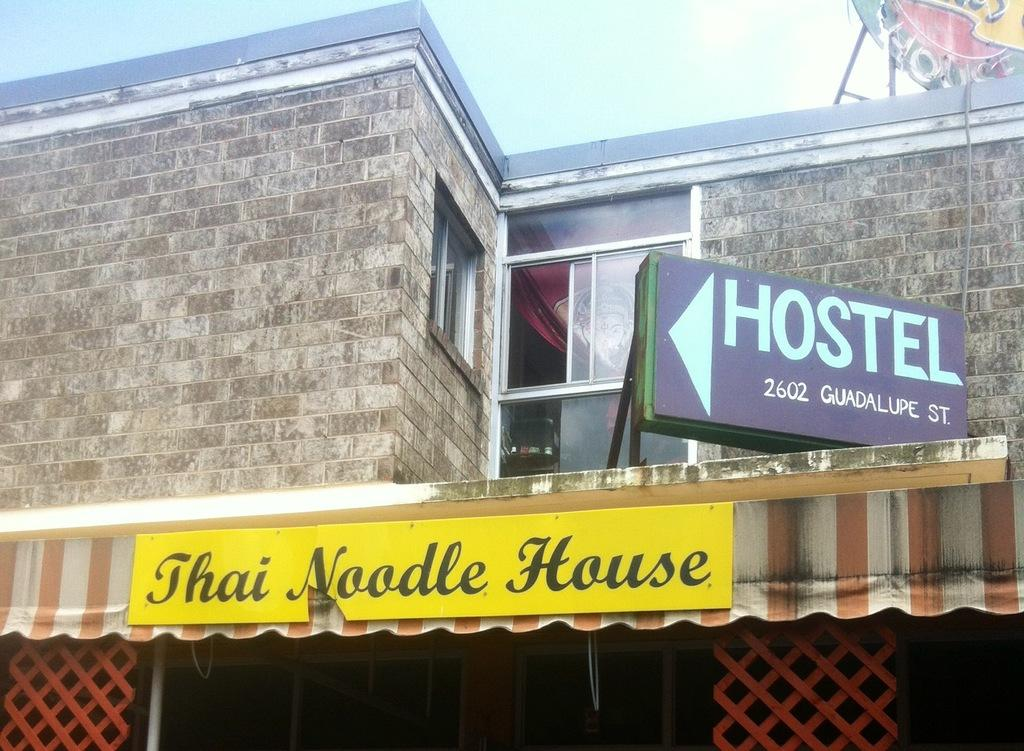What is located on the right side of the image? There is a hoarding on the right side of the image. What type of material is used for the windows visible in the image? The windows visible in the image are made of glass. What reason does the hoarding give for falling down in the image? There is no indication in the image that the hoarding is falling down, so it cannot be determined from the picture. 